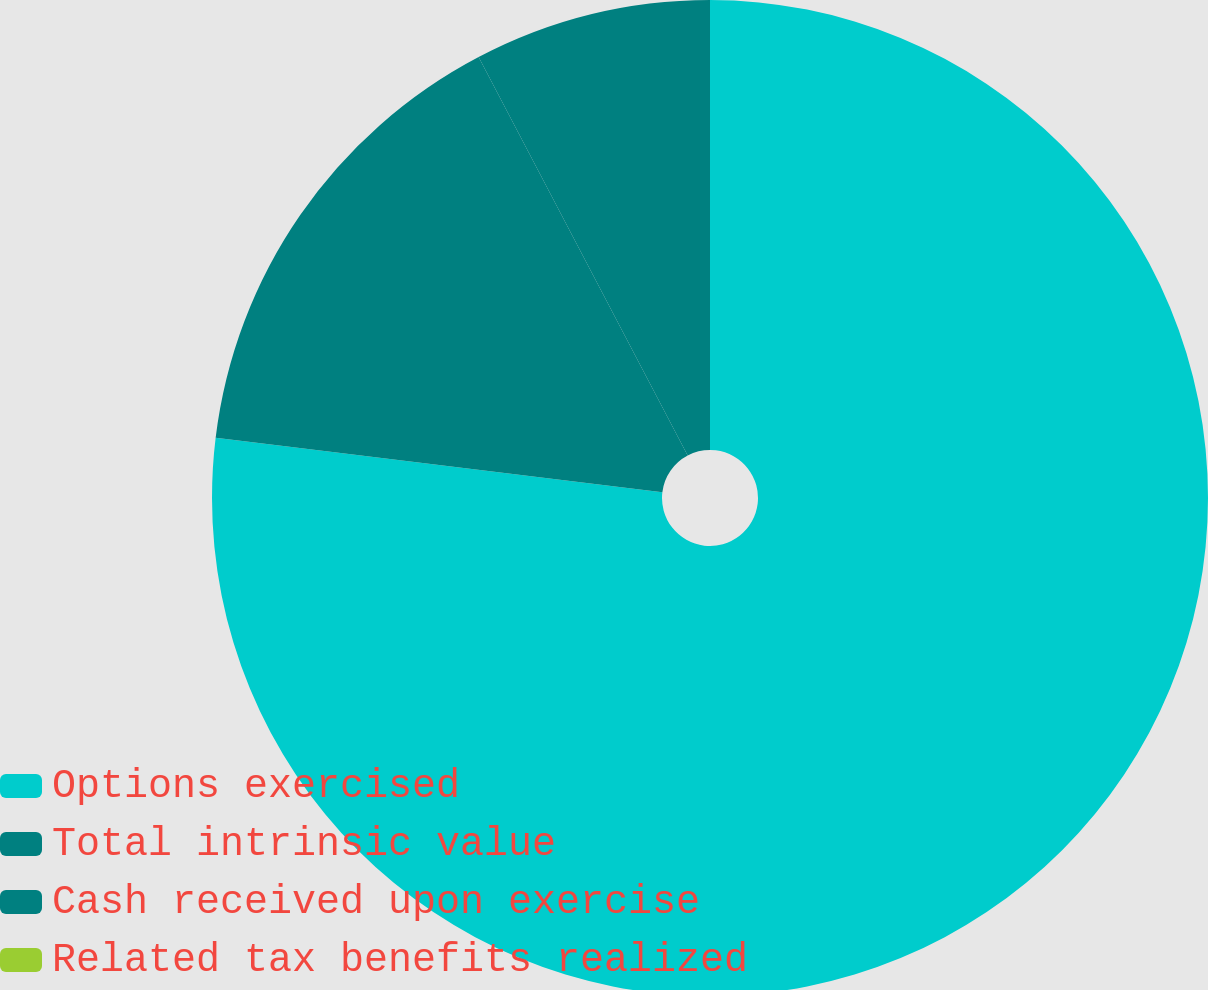<chart> <loc_0><loc_0><loc_500><loc_500><pie_chart><fcel>Options exercised<fcel>Total intrinsic value<fcel>Cash received upon exercise<fcel>Related tax benefits realized<nl><fcel>76.92%<fcel>15.38%<fcel>7.69%<fcel>0.0%<nl></chart> 